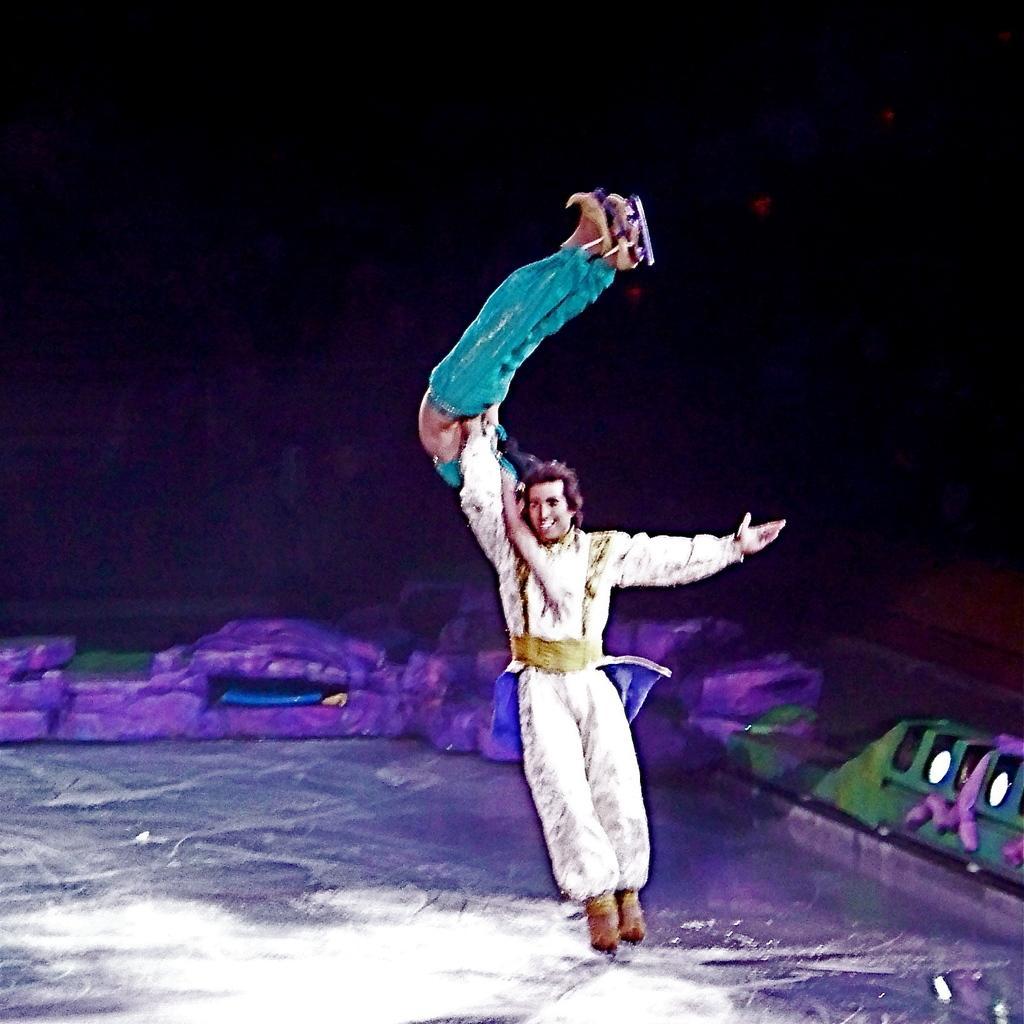Could you give a brief overview of what you see in this image? In this image I can see two persons where I can see one is wearing white colour dress and one is wearing blue. I can see smile on his face and I can also see this image is little bit blurry. I can also see this image is little bit in dark from background. 